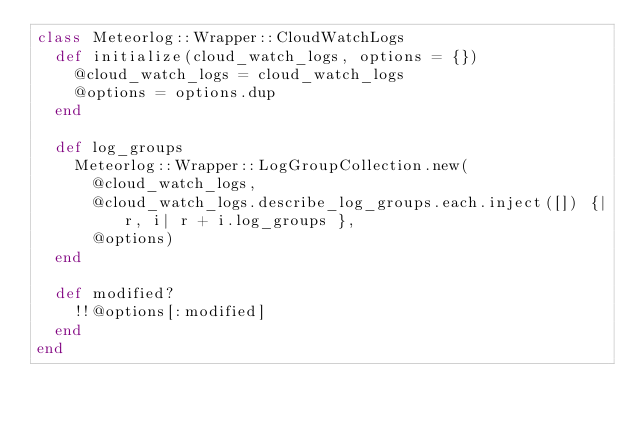<code> <loc_0><loc_0><loc_500><loc_500><_Ruby_>class Meteorlog::Wrapper::CloudWatchLogs
  def initialize(cloud_watch_logs, options = {})
    @cloud_watch_logs = cloud_watch_logs
    @options = options.dup
  end

  def log_groups
    Meteorlog::Wrapper::LogGroupCollection.new(
      @cloud_watch_logs,
      @cloud_watch_logs.describe_log_groups.each.inject([]) {|r, i| r + i.log_groups },
      @options)
  end

  def modified?
    !!@options[:modified]
  end
end
</code> 